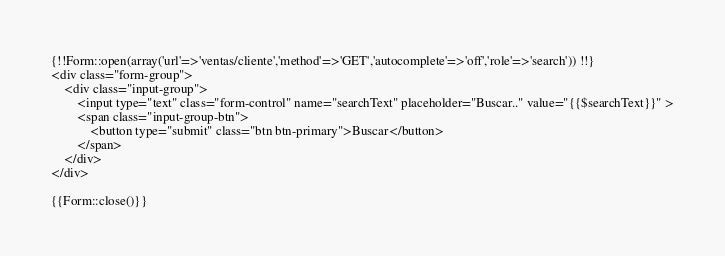Convert code to text. <code><loc_0><loc_0><loc_500><loc_500><_PHP_>{!!Form::open(array('url'=>'ventas/cliente','method'=>'GET','autocomplete'=>'off','role'=>'search')) !!}
<div class="form-group">
	<div class="input-group">
		<input type="text" class="form-control" name="searchText" placeholder="Buscar.." value="{{$searchText}}" >
		<span class="input-group-btn">
			<button type="submit" class="btn btn-primary">Buscar</button>
		</span>
	</div>
</div>

{{Form::close()}}</code> 